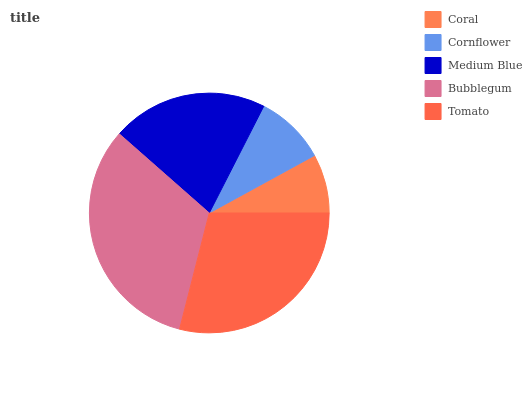Is Coral the minimum?
Answer yes or no. Yes. Is Bubblegum the maximum?
Answer yes or no. Yes. Is Cornflower the minimum?
Answer yes or no. No. Is Cornflower the maximum?
Answer yes or no. No. Is Cornflower greater than Coral?
Answer yes or no. Yes. Is Coral less than Cornflower?
Answer yes or no. Yes. Is Coral greater than Cornflower?
Answer yes or no. No. Is Cornflower less than Coral?
Answer yes or no. No. Is Medium Blue the high median?
Answer yes or no. Yes. Is Medium Blue the low median?
Answer yes or no. Yes. Is Coral the high median?
Answer yes or no. No. Is Cornflower the low median?
Answer yes or no. No. 